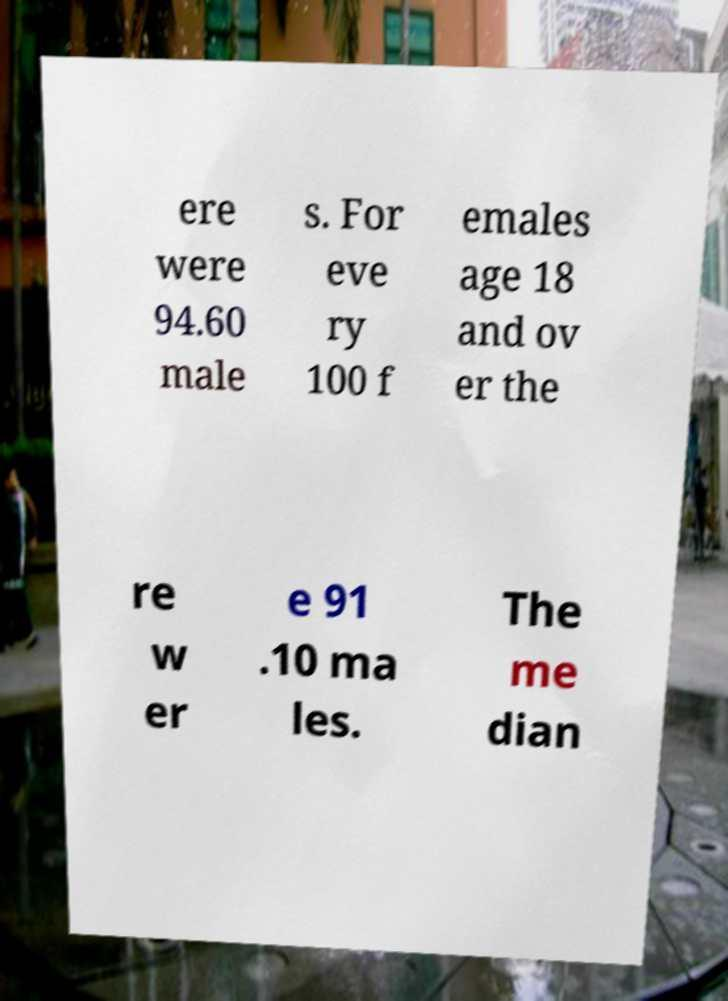Please identify and transcribe the text found in this image. ere were 94.60 male s. For eve ry 100 f emales age 18 and ov er the re w er e 91 .10 ma les. The me dian 